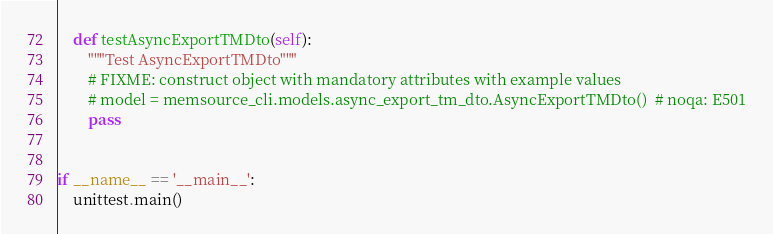<code> <loc_0><loc_0><loc_500><loc_500><_Python_>
    def testAsyncExportTMDto(self):
        """Test AsyncExportTMDto"""
        # FIXME: construct object with mandatory attributes with example values
        # model = memsource_cli.models.async_export_tm_dto.AsyncExportTMDto()  # noqa: E501
        pass


if __name__ == '__main__':
    unittest.main()
</code> 